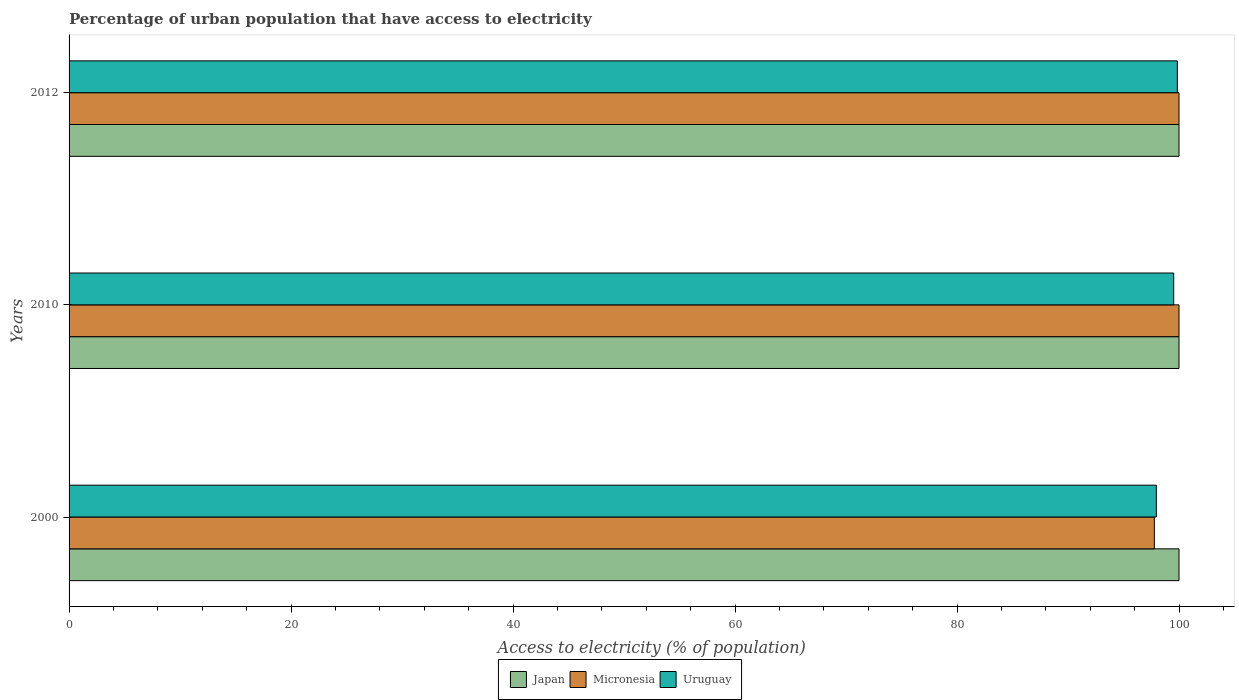How many different coloured bars are there?
Your answer should be very brief. 3. Are the number of bars per tick equal to the number of legend labels?
Offer a very short reply. Yes. How many bars are there on the 1st tick from the top?
Offer a terse response. 3. Across all years, what is the maximum percentage of urban population that have access to electricity in Micronesia?
Make the answer very short. 100. Across all years, what is the minimum percentage of urban population that have access to electricity in Japan?
Offer a very short reply. 100. What is the total percentage of urban population that have access to electricity in Japan in the graph?
Provide a short and direct response. 300. What is the difference between the percentage of urban population that have access to electricity in Uruguay in 2000 and that in 2010?
Your answer should be compact. -1.56. What is the difference between the percentage of urban population that have access to electricity in Uruguay in 2000 and the percentage of urban population that have access to electricity in Micronesia in 2012?
Provide a short and direct response. -2.04. What is the average percentage of urban population that have access to electricity in Uruguay per year?
Make the answer very short. 99.11. In the year 2010, what is the difference between the percentage of urban population that have access to electricity in Japan and percentage of urban population that have access to electricity in Micronesia?
Offer a very short reply. 0. In how many years, is the percentage of urban population that have access to electricity in Micronesia greater than 12 %?
Ensure brevity in your answer.  3. What is the ratio of the percentage of urban population that have access to electricity in Micronesia in 2000 to that in 2012?
Ensure brevity in your answer.  0.98. What is the difference between the highest and the second highest percentage of urban population that have access to electricity in Uruguay?
Make the answer very short. 0.33. What is the difference between the highest and the lowest percentage of urban population that have access to electricity in Japan?
Offer a terse response. 0. In how many years, is the percentage of urban population that have access to electricity in Micronesia greater than the average percentage of urban population that have access to electricity in Micronesia taken over all years?
Your answer should be compact. 2. What does the 2nd bar from the top in 2010 represents?
Keep it short and to the point. Micronesia. What does the 1st bar from the bottom in 2012 represents?
Ensure brevity in your answer.  Japan. Is it the case that in every year, the sum of the percentage of urban population that have access to electricity in Uruguay and percentage of urban population that have access to electricity in Micronesia is greater than the percentage of urban population that have access to electricity in Japan?
Your answer should be compact. Yes. How many years are there in the graph?
Offer a very short reply. 3. Are the values on the major ticks of X-axis written in scientific E-notation?
Provide a succinct answer. No. Does the graph contain any zero values?
Keep it short and to the point. No. Where does the legend appear in the graph?
Offer a very short reply. Bottom center. How many legend labels are there?
Make the answer very short. 3. How are the legend labels stacked?
Offer a very short reply. Horizontal. What is the title of the graph?
Offer a terse response. Percentage of urban population that have access to electricity. What is the label or title of the X-axis?
Provide a short and direct response. Access to electricity (% of population). What is the label or title of the Y-axis?
Your answer should be compact. Years. What is the Access to electricity (% of population) in Micronesia in 2000?
Provide a succinct answer. 97.78. What is the Access to electricity (% of population) of Uruguay in 2000?
Keep it short and to the point. 97.96. What is the Access to electricity (% of population) of Japan in 2010?
Offer a very short reply. 100. What is the Access to electricity (% of population) in Uruguay in 2010?
Your answer should be compact. 99.52. What is the Access to electricity (% of population) of Uruguay in 2012?
Your answer should be very brief. 99.85. Across all years, what is the maximum Access to electricity (% of population) of Japan?
Offer a terse response. 100. Across all years, what is the maximum Access to electricity (% of population) in Micronesia?
Provide a short and direct response. 100. Across all years, what is the maximum Access to electricity (% of population) in Uruguay?
Make the answer very short. 99.85. Across all years, what is the minimum Access to electricity (% of population) in Micronesia?
Your answer should be very brief. 97.78. Across all years, what is the minimum Access to electricity (% of population) of Uruguay?
Provide a succinct answer. 97.96. What is the total Access to electricity (% of population) in Japan in the graph?
Your answer should be compact. 300. What is the total Access to electricity (% of population) of Micronesia in the graph?
Offer a very short reply. 297.78. What is the total Access to electricity (% of population) of Uruguay in the graph?
Offer a terse response. 297.33. What is the difference between the Access to electricity (% of population) in Japan in 2000 and that in 2010?
Provide a short and direct response. 0. What is the difference between the Access to electricity (% of population) in Micronesia in 2000 and that in 2010?
Your answer should be very brief. -2.22. What is the difference between the Access to electricity (% of population) of Uruguay in 2000 and that in 2010?
Give a very brief answer. -1.56. What is the difference between the Access to electricity (% of population) of Japan in 2000 and that in 2012?
Your answer should be compact. 0. What is the difference between the Access to electricity (% of population) of Micronesia in 2000 and that in 2012?
Offer a terse response. -2.22. What is the difference between the Access to electricity (% of population) in Uruguay in 2000 and that in 2012?
Make the answer very short. -1.89. What is the difference between the Access to electricity (% of population) of Japan in 2010 and that in 2012?
Give a very brief answer. 0. What is the difference between the Access to electricity (% of population) of Uruguay in 2010 and that in 2012?
Make the answer very short. -0.33. What is the difference between the Access to electricity (% of population) of Japan in 2000 and the Access to electricity (% of population) of Micronesia in 2010?
Provide a succinct answer. 0. What is the difference between the Access to electricity (% of population) of Japan in 2000 and the Access to electricity (% of population) of Uruguay in 2010?
Provide a succinct answer. 0.48. What is the difference between the Access to electricity (% of population) in Micronesia in 2000 and the Access to electricity (% of population) in Uruguay in 2010?
Your answer should be compact. -1.74. What is the difference between the Access to electricity (% of population) of Japan in 2000 and the Access to electricity (% of population) of Micronesia in 2012?
Your answer should be very brief. 0. What is the difference between the Access to electricity (% of population) of Japan in 2000 and the Access to electricity (% of population) of Uruguay in 2012?
Offer a very short reply. 0.15. What is the difference between the Access to electricity (% of population) of Micronesia in 2000 and the Access to electricity (% of population) of Uruguay in 2012?
Offer a very short reply. -2.07. What is the difference between the Access to electricity (% of population) of Japan in 2010 and the Access to electricity (% of population) of Uruguay in 2012?
Your answer should be compact. 0.15. What is the difference between the Access to electricity (% of population) in Micronesia in 2010 and the Access to electricity (% of population) in Uruguay in 2012?
Offer a very short reply. 0.15. What is the average Access to electricity (% of population) in Japan per year?
Your response must be concise. 100. What is the average Access to electricity (% of population) of Micronesia per year?
Provide a short and direct response. 99.26. What is the average Access to electricity (% of population) in Uruguay per year?
Offer a terse response. 99.11. In the year 2000, what is the difference between the Access to electricity (% of population) in Japan and Access to electricity (% of population) in Micronesia?
Keep it short and to the point. 2.22. In the year 2000, what is the difference between the Access to electricity (% of population) of Japan and Access to electricity (% of population) of Uruguay?
Keep it short and to the point. 2.04. In the year 2000, what is the difference between the Access to electricity (% of population) in Micronesia and Access to electricity (% of population) in Uruguay?
Offer a terse response. -0.18. In the year 2010, what is the difference between the Access to electricity (% of population) of Japan and Access to electricity (% of population) of Micronesia?
Ensure brevity in your answer.  0. In the year 2010, what is the difference between the Access to electricity (% of population) in Japan and Access to electricity (% of population) in Uruguay?
Your answer should be very brief. 0.48. In the year 2010, what is the difference between the Access to electricity (% of population) in Micronesia and Access to electricity (% of population) in Uruguay?
Make the answer very short. 0.48. In the year 2012, what is the difference between the Access to electricity (% of population) in Japan and Access to electricity (% of population) in Uruguay?
Give a very brief answer. 0.15. In the year 2012, what is the difference between the Access to electricity (% of population) in Micronesia and Access to electricity (% of population) in Uruguay?
Your response must be concise. 0.15. What is the ratio of the Access to electricity (% of population) in Japan in 2000 to that in 2010?
Your response must be concise. 1. What is the ratio of the Access to electricity (% of population) in Micronesia in 2000 to that in 2010?
Make the answer very short. 0.98. What is the ratio of the Access to electricity (% of population) of Uruguay in 2000 to that in 2010?
Your answer should be compact. 0.98. What is the ratio of the Access to electricity (% of population) of Japan in 2000 to that in 2012?
Provide a short and direct response. 1. What is the ratio of the Access to electricity (% of population) of Micronesia in 2000 to that in 2012?
Provide a succinct answer. 0.98. What is the ratio of the Access to electricity (% of population) in Uruguay in 2000 to that in 2012?
Your response must be concise. 0.98. What is the ratio of the Access to electricity (% of population) of Micronesia in 2010 to that in 2012?
Your response must be concise. 1. What is the difference between the highest and the second highest Access to electricity (% of population) in Micronesia?
Keep it short and to the point. 0. What is the difference between the highest and the second highest Access to electricity (% of population) in Uruguay?
Your response must be concise. 0.33. What is the difference between the highest and the lowest Access to electricity (% of population) of Micronesia?
Keep it short and to the point. 2.22. What is the difference between the highest and the lowest Access to electricity (% of population) in Uruguay?
Offer a very short reply. 1.89. 